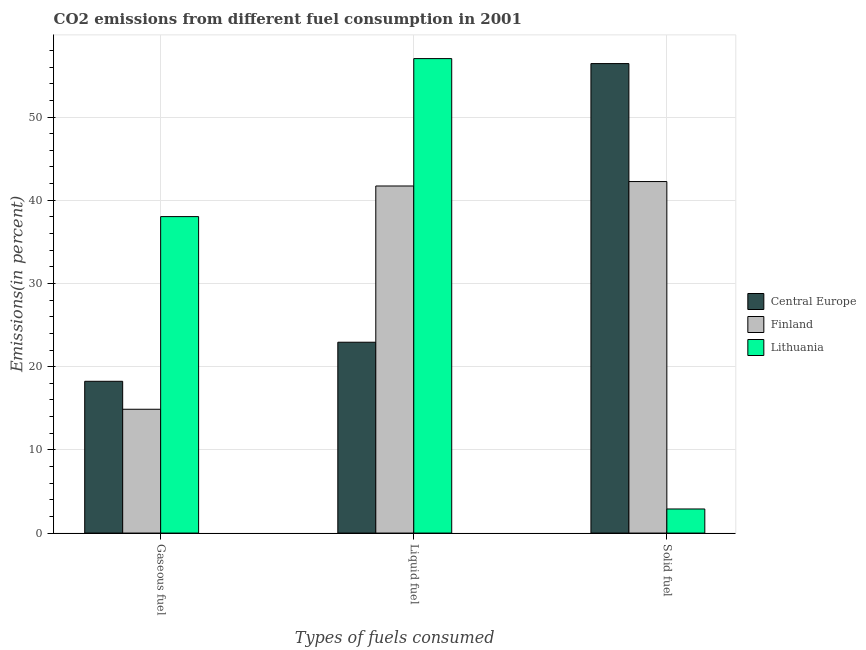How many different coloured bars are there?
Your response must be concise. 3. How many groups of bars are there?
Provide a short and direct response. 3. Are the number of bars per tick equal to the number of legend labels?
Your response must be concise. Yes. Are the number of bars on each tick of the X-axis equal?
Keep it short and to the point. Yes. What is the label of the 3rd group of bars from the left?
Keep it short and to the point. Solid fuel. What is the percentage of solid fuel emission in Finland?
Provide a short and direct response. 42.25. Across all countries, what is the maximum percentage of liquid fuel emission?
Your response must be concise. 57.03. Across all countries, what is the minimum percentage of solid fuel emission?
Your answer should be very brief. 2.9. In which country was the percentage of solid fuel emission maximum?
Provide a succinct answer. Central Europe. In which country was the percentage of solid fuel emission minimum?
Ensure brevity in your answer.  Lithuania. What is the total percentage of solid fuel emission in the graph?
Offer a very short reply. 101.57. What is the difference between the percentage of gaseous fuel emission in Finland and that in Central Europe?
Offer a terse response. -3.36. What is the difference between the percentage of solid fuel emission in Finland and the percentage of gaseous fuel emission in Lithuania?
Make the answer very short. 4.21. What is the average percentage of solid fuel emission per country?
Provide a succinct answer. 33.86. What is the difference between the percentage of solid fuel emission and percentage of gaseous fuel emission in Central Europe?
Ensure brevity in your answer.  38.18. In how many countries, is the percentage of gaseous fuel emission greater than 2 %?
Give a very brief answer. 3. What is the ratio of the percentage of liquid fuel emission in Lithuania to that in Finland?
Your answer should be compact. 1.37. Is the percentage of solid fuel emission in Lithuania less than that in Finland?
Provide a succinct answer. Yes. Is the difference between the percentage of gaseous fuel emission in Central Europe and Lithuania greater than the difference between the percentage of solid fuel emission in Central Europe and Lithuania?
Provide a succinct answer. No. What is the difference between the highest and the second highest percentage of gaseous fuel emission?
Keep it short and to the point. 19.79. What is the difference between the highest and the lowest percentage of solid fuel emission?
Offer a terse response. 53.53. In how many countries, is the percentage of gaseous fuel emission greater than the average percentage of gaseous fuel emission taken over all countries?
Keep it short and to the point. 1. Is the sum of the percentage of solid fuel emission in Lithuania and Finland greater than the maximum percentage of liquid fuel emission across all countries?
Offer a terse response. No. What does the 3rd bar from the left in Liquid fuel represents?
Provide a succinct answer. Lithuania. What does the 1st bar from the right in Solid fuel represents?
Offer a very short reply. Lithuania. How many bars are there?
Provide a succinct answer. 9. What is the difference between two consecutive major ticks on the Y-axis?
Ensure brevity in your answer.  10. Where does the legend appear in the graph?
Give a very brief answer. Center right. How many legend labels are there?
Your response must be concise. 3. How are the legend labels stacked?
Make the answer very short. Vertical. What is the title of the graph?
Provide a short and direct response. CO2 emissions from different fuel consumption in 2001. Does "El Salvador" appear as one of the legend labels in the graph?
Make the answer very short. No. What is the label or title of the X-axis?
Offer a very short reply. Types of fuels consumed. What is the label or title of the Y-axis?
Your answer should be very brief. Emissions(in percent). What is the Emissions(in percent) in Central Europe in Gaseous fuel?
Your answer should be compact. 18.24. What is the Emissions(in percent) of Finland in Gaseous fuel?
Ensure brevity in your answer.  14.88. What is the Emissions(in percent) of Lithuania in Gaseous fuel?
Your answer should be very brief. 38.04. What is the Emissions(in percent) of Central Europe in Liquid fuel?
Offer a very short reply. 22.94. What is the Emissions(in percent) of Finland in Liquid fuel?
Offer a terse response. 41.71. What is the Emissions(in percent) of Lithuania in Liquid fuel?
Offer a terse response. 57.03. What is the Emissions(in percent) in Central Europe in Solid fuel?
Provide a succinct answer. 56.43. What is the Emissions(in percent) of Finland in Solid fuel?
Offer a very short reply. 42.25. What is the Emissions(in percent) in Lithuania in Solid fuel?
Provide a succinct answer. 2.9. Across all Types of fuels consumed, what is the maximum Emissions(in percent) in Central Europe?
Ensure brevity in your answer.  56.43. Across all Types of fuels consumed, what is the maximum Emissions(in percent) of Finland?
Give a very brief answer. 42.25. Across all Types of fuels consumed, what is the maximum Emissions(in percent) in Lithuania?
Make the answer very short. 57.03. Across all Types of fuels consumed, what is the minimum Emissions(in percent) of Central Europe?
Your response must be concise. 18.24. Across all Types of fuels consumed, what is the minimum Emissions(in percent) in Finland?
Provide a short and direct response. 14.88. Across all Types of fuels consumed, what is the minimum Emissions(in percent) of Lithuania?
Keep it short and to the point. 2.9. What is the total Emissions(in percent) in Central Europe in the graph?
Your answer should be compact. 97.6. What is the total Emissions(in percent) in Finland in the graph?
Provide a short and direct response. 98.84. What is the total Emissions(in percent) of Lithuania in the graph?
Your response must be concise. 97.96. What is the difference between the Emissions(in percent) in Central Europe in Gaseous fuel and that in Liquid fuel?
Provide a short and direct response. -4.69. What is the difference between the Emissions(in percent) of Finland in Gaseous fuel and that in Liquid fuel?
Ensure brevity in your answer.  -26.84. What is the difference between the Emissions(in percent) in Lithuania in Gaseous fuel and that in Liquid fuel?
Offer a very short reply. -18.99. What is the difference between the Emissions(in percent) of Central Europe in Gaseous fuel and that in Solid fuel?
Keep it short and to the point. -38.18. What is the difference between the Emissions(in percent) of Finland in Gaseous fuel and that in Solid fuel?
Your answer should be very brief. -27.37. What is the difference between the Emissions(in percent) of Lithuania in Gaseous fuel and that in Solid fuel?
Give a very brief answer. 35.14. What is the difference between the Emissions(in percent) of Central Europe in Liquid fuel and that in Solid fuel?
Give a very brief answer. -33.49. What is the difference between the Emissions(in percent) of Finland in Liquid fuel and that in Solid fuel?
Offer a very short reply. -0.53. What is the difference between the Emissions(in percent) in Lithuania in Liquid fuel and that in Solid fuel?
Make the answer very short. 54.13. What is the difference between the Emissions(in percent) of Central Europe in Gaseous fuel and the Emissions(in percent) of Finland in Liquid fuel?
Make the answer very short. -23.47. What is the difference between the Emissions(in percent) in Central Europe in Gaseous fuel and the Emissions(in percent) in Lithuania in Liquid fuel?
Your answer should be compact. -38.78. What is the difference between the Emissions(in percent) in Finland in Gaseous fuel and the Emissions(in percent) in Lithuania in Liquid fuel?
Your response must be concise. -42.15. What is the difference between the Emissions(in percent) of Central Europe in Gaseous fuel and the Emissions(in percent) of Finland in Solid fuel?
Your answer should be compact. -24.01. What is the difference between the Emissions(in percent) in Central Europe in Gaseous fuel and the Emissions(in percent) in Lithuania in Solid fuel?
Your response must be concise. 15.35. What is the difference between the Emissions(in percent) in Finland in Gaseous fuel and the Emissions(in percent) in Lithuania in Solid fuel?
Ensure brevity in your answer.  11.98. What is the difference between the Emissions(in percent) of Central Europe in Liquid fuel and the Emissions(in percent) of Finland in Solid fuel?
Make the answer very short. -19.31. What is the difference between the Emissions(in percent) in Central Europe in Liquid fuel and the Emissions(in percent) in Lithuania in Solid fuel?
Make the answer very short. 20.04. What is the difference between the Emissions(in percent) in Finland in Liquid fuel and the Emissions(in percent) in Lithuania in Solid fuel?
Provide a succinct answer. 38.82. What is the average Emissions(in percent) in Central Europe per Types of fuels consumed?
Offer a very short reply. 32.53. What is the average Emissions(in percent) of Finland per Types of fuels consumed?
Offer a very short reply. 32.95. What is the average Emissions(in percent) of Lithuania per Types of fuels consumed?
Offer a terse response. 32.65. What is the difference between the Emissions(in percent) of Central Europe and Emissions(in percent) of Finland in Gaseous fuel?
Offer a very short reply. 3.36. What is the difference between the Emissions(in percent) of Central Europe and Emissions(in percent) of Lithuania in Gaseous fuel?
Make the answer very short. -19.79. What is the difference between the Emissions(in percent) of Finland and Emissions(in percent) of Lithuania in Gaseous fuel?
Make the answer very short. -23.16. What is the difference between the Emissions(in percent) of Central Europe and Emissions(in percent) of Finland in Liquid fuel?
Ensure brevity in your answer.  -18.78. What is the difference between the Emissions(in percent) in Central Europe and Emissions(in percent) in Lithuania in Liquid fuel?
Provide a succinct answer. -34.09. What is the difference between the Emissions(in percent) in Finland and Emissions(in percent) in Lithuania in Liquid fuel?
Provide a succinct answer. -15.31. What is the difference between the Emissions(in percent) in Central Europe and Emissions(in percent) in Finland in Solid fuel?
Ensure brevity in your answer.  14.18. What is the difference between the Emissions(in percent) of Central Europe and Emissions(in percent) of Lithuania in Solid fuel?
Offer a very short reply. 53.53. What is the difference between the Emissions(in percent) in Finland and Emissions(in percent) in Lithuania in Solid fuel?
Provide a succinct answer. 39.35. What is the ratio of the Emissions(in percent) in Central Europe in Gaseous fuel to that in Liquid fuel?
Provide a short and direct response. 0.8. What is the ratio of the Emissions(in percent) in Finland in Gaseous fuel to that in Liquid fuel?
Make the answer very short. 0.36. What is the ratio of the Emissions(in percent) in Lithuania in Gaseous fuel to that in Liquid fuel?
Offer a terse response. 0.67. What is the ratio of the Emissions(in percent) of Central Europe in Gaseous fuel to that in Solid fuel?
Your answer should be very brief. 0.32. What is the ratio of the Emissions(in percent) of Finland in Gaseous fuel to that in Solid fuel?
Your response must be concise. 0.35. What is the ratio of the Emissions(in percent) in Lithuania in Gaseous fuel to that in Solid fuel?
Provide a succinct answer. 13.14. What is the ratio of the Emissions(in percent) in Central Europe in Liquid fuel to that in Solid fuel?
Provide a short and direct response. 0.41. What is the ratio of the Emissions(in percent) of Finland in Liquid fuel to that in Solid fuel?
Provide a succinct answer. 0.99. What is the ratio of the Emissions(in percent) of Lithuania in Liquid fuel to that in Solid fuel?
Your answer should be compact. 19.7. What is the difference between the highest and the second highest Emissions(in percent) of Central Europe?
Offer a very short reply. 33.49. What is the difference between the highest and the second highest Emissions(in percent) in Finland?
Keep it short and to the point. 0.53. What is the difference between the highest and the second highest Emissions(in percent) in Lithuania?
Keep it short and to the point. 18.99. What is the difference between the highest and the lowest Emissions(in percent) of Central Europe?
Keep it short and to the point. 38.18. What is the difference between the highest and the lowest Emissions(in percent) of Finland?
Offer a very short reply. 27.37. What is the difference between the highest and the lowest Emissions(in percent) of Lithuania?
Give a very brief answer. 54.13. 